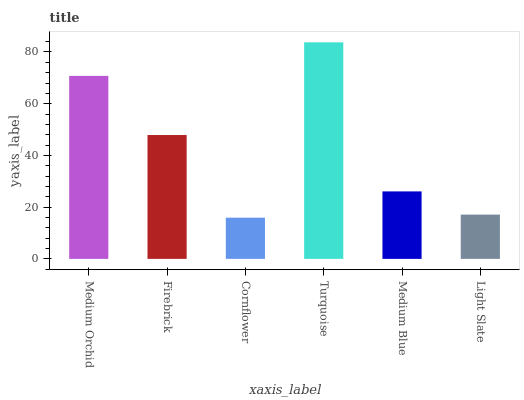Is Firebrick the minimum?
Answer yes or no. No. Is Firebrick the maximum?
Answer yes or no. No. Is Medium Orchid greater than Firebrick?
Answer yes or no. Yes. Is Firebrick less than Medium Orchid?
Answer yes or no. Yes. Is Firebrick greater than Medium Orchid?
Answer yes or no. No. Is Medium Orchid less than Firebrick?
Answer yes or no. No. Is Firebrick the high median?
Answer yes or no. Yes. Is Medium Blue the low median?
Answer yes or no. Yes. Is Turquoise the high median?
Answer yes or no. No. Is Medium Orchid the low median?
Answer yes or no. No. 